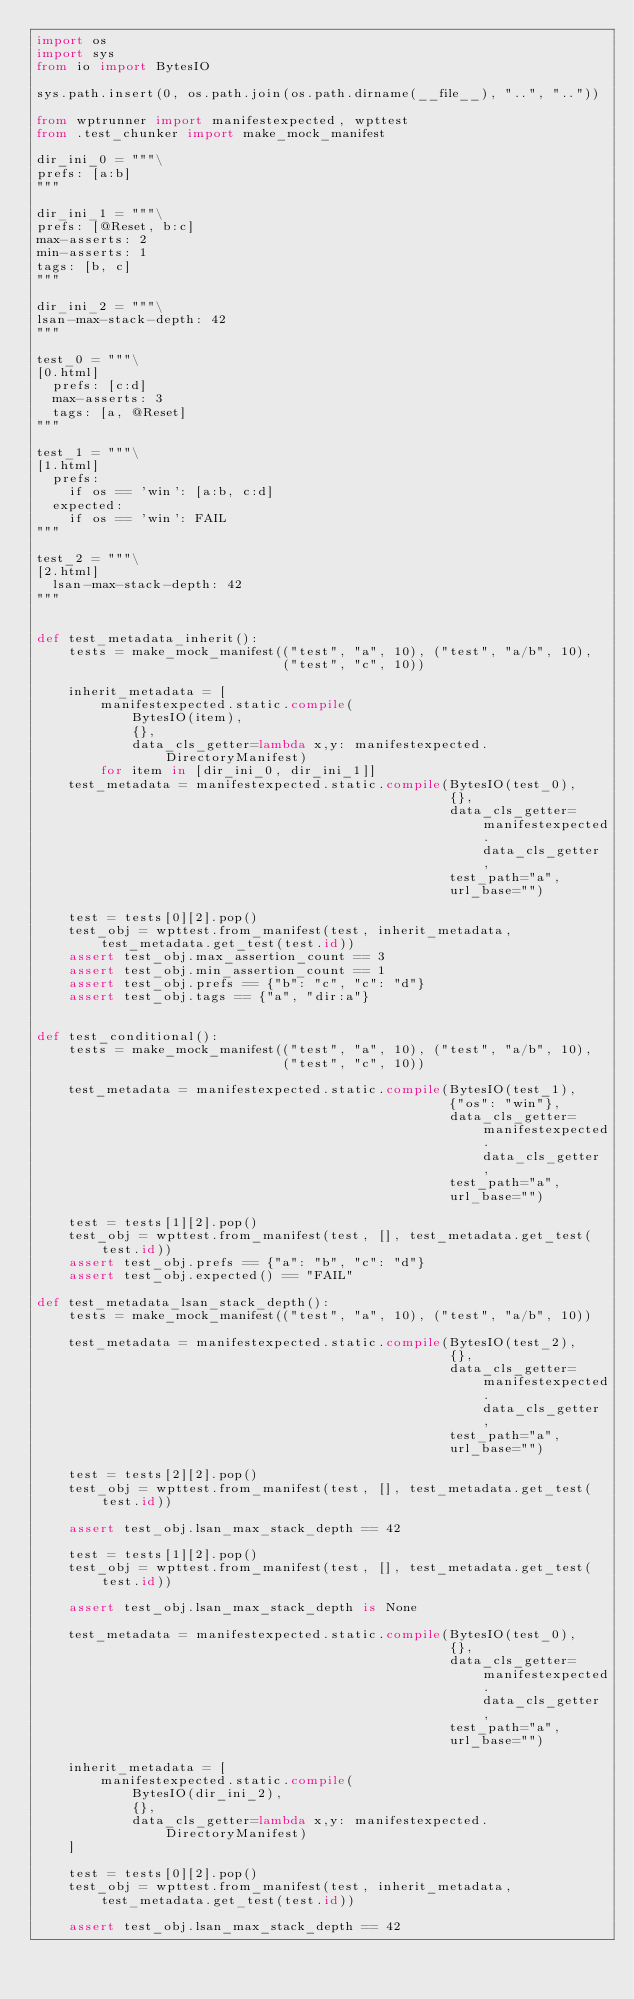Convert code to text. <code><loc_0><loc_0><loc_500><loc_500><_Python_>import os
import sys
from io import BytesIO

sys.path.insert(0, os.path.join(os.path.dirname(__file__), "..", ".."))

from wptrunner import manifestexpected, wpttest
from .test_chunker import make_mock_manifest

dir_ini_0 = """\
prefs: [a:b]
"""

dir_ini_1 = """\
prefs: [@Reset, b:c]
max-asserts: 2
min-asserts: 1
tags: [b, c]
"""

dir_ini_2 = """\
lsan-max-stack-depth: 42
"""

test_0 = """\
[0.html]
  prefs: [c:d]
  max-asserts: 3
  tags: [a, @Reset]
"""

test_1 = """\
[1.html]
  prefs:
    if os == 'win': [a:b, c:d]
  expected:
    if os == 'win': FAIL
"""

test_2 = """\
[2.html]
  lsan-max-stack-depth: 42
"""


def test_metadata_inherit():
    tests = make_mock_manifest(("test", "a", 10), ("test", "a/b", 10),
                               ("test", "c", 10))

    inherit_metadata = [
        manifestexpected.static.compile(
            BytesIO(item),
            {},
            data_cls_getter=lambda x,y: manifestexpected.DirectoryManifest)
        for item in [dir_ini_0, dir_ini_1]]
    test_metadata = manifestexpected.static.compile(BytesIO(test_0),
                                                    {},
                                                    data_cls_getter=manifestexpected.data_cls_getter,
                                                    test_path="a",
                                                    url_base="")

    test = tests[0][2].pop()
    test_obj = wpttest.from_manifest(test, inherit_metadata, test_metadata.get_test(test.id))
    assert test_obj.max_assertion_count == 3
    assert test_obj.min_assertion_count == 1
    assert test_obj.prefs == {"b": "c", "c": "d"}
    assert test_obj.tags == {"a", "dir:a"}


def test_conditional():
    tests = make_mock_manifest(("test", "a", 10), ("test", "a/b", 10),
                               ("test", "c", 10))

    test_metadata = manifestexpected.static.compile(BytesIO(test_1),
                                                    {"os": "win"},
                                                    data_cls_getter=manifestexpected.data_cls_getter,
                                                    test_path="a",
                                                    url_base="")

    test = tests[1][2].pop()
    test_obj = wpttest.from_manifest(test, [], test_metadata.get_test(test.id))
    assert test_obj.prefs == {"a": "b", "c": "d"}
    assert test_obj.expected() == "FAIL"

def test_metadata_lsan_stack_depth():
    tests = make_mock_manifest(("test", "a", 10), ("test", "a/b", 10))

    test_metadata = manifestexpected.static.compile(BytesIO(test_2),
                                                    {},
                                                    data_cls_getter=manifestexpected.data_cls_getter,
                                                    test_path="a",
                                                    url_base="")

    test = tests[2][2].pop()
    test_obj = wpttest.from_manifest(test, [], test_metadata.get_test(test.id))

    assert test_obj.lsan_max_stack_depth == 42

    test = tests[1][2].pop()
    test_obj = wpttest.from_manifest(test, [], test_metadata.get_test(test.id))

    assert test_obj.lsan_max_stack_depth is None

    test_metadata = manifestexpected.static.compile(BytesIO(test_0),
                                                    {},
                                                    data_cls_getter=manifestexpected.data_cls_getter,
                                                    test_path="a",
                                                    url_base="")

    inherit_metadata = [
        manifestexpected.static.compile(
            BytesIO(dir_ini_2),
            {},
            data_cls_getter=lambda x,y: manifestexpected.DirectoryManifest)
    ]

    test = tests[0][2].pop()
    test_obj = wpttest.from_manifest(test, inherit_metadata, test_metadata.get_test(test.id))

    assert test_obj.lsan_max_stack_depth == 42
</code> 